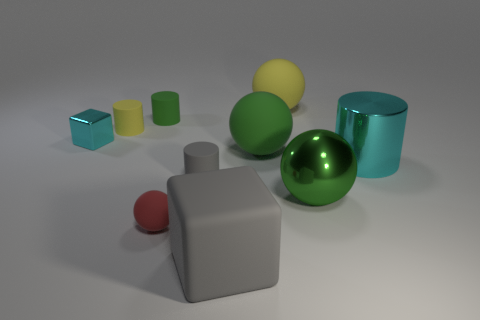Subtract 1 cylinders. How many cylinders are left? 3 Subtract all blocks. How many objects are left? 8 Subtract all green objects. Subtract all big brown blocks. How many objects are left? 7 Add 8 big yellow balls. How many big yellow balls are left? 9 Add 9 large cylinders. How many large cylinders exist? 10 Subtract 0 brown cubes. How many objects are left? 10 